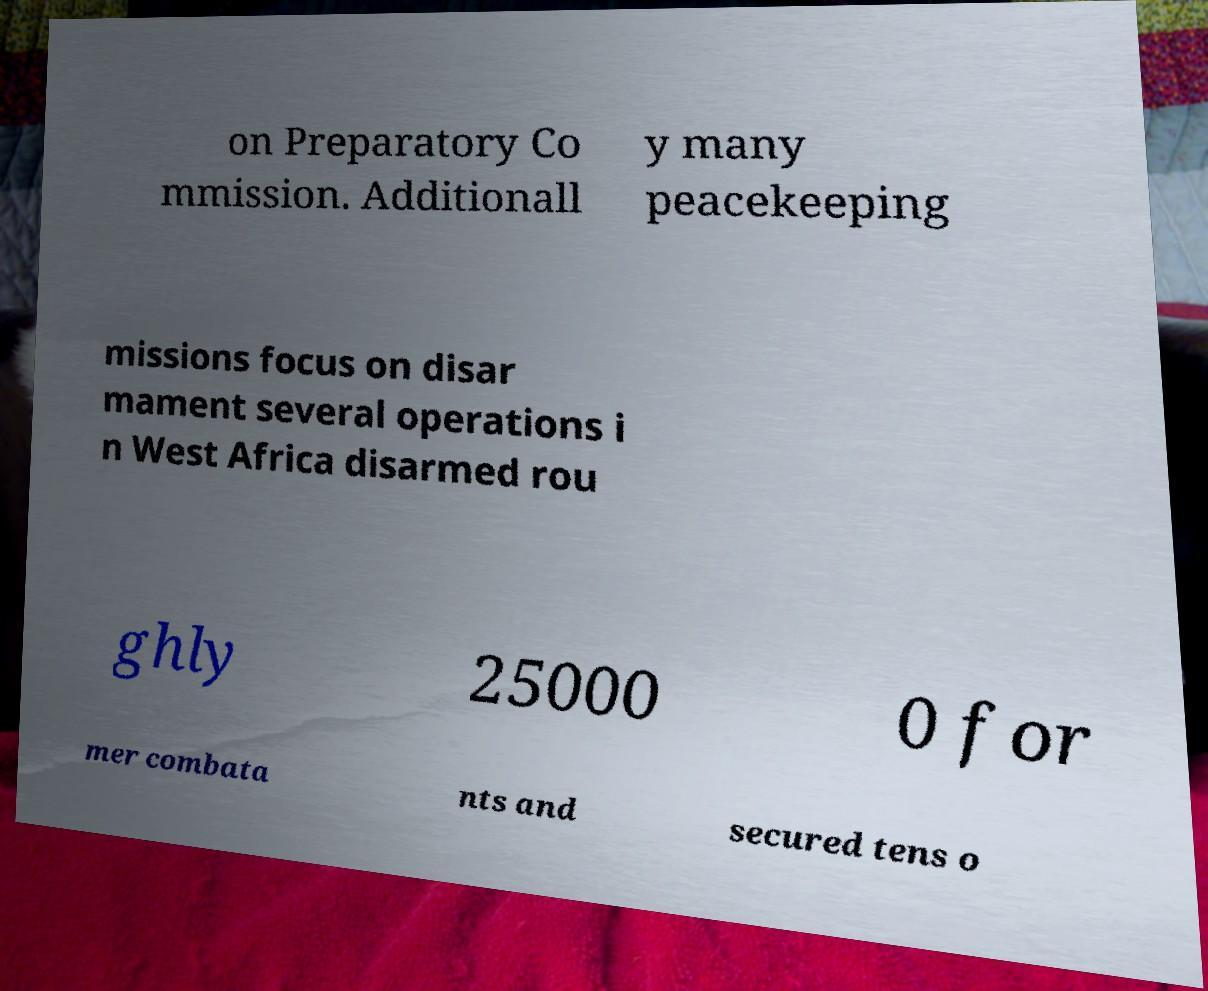What messages or text are displayed in this image? I need them in a readable, typed format. on Preparatory Co mmission. Additionall y many peacekeeping missions focus on disar mament several operations i n West Africa disarmed rou ghly 25000 0 for mer combata nts and secured tens o 